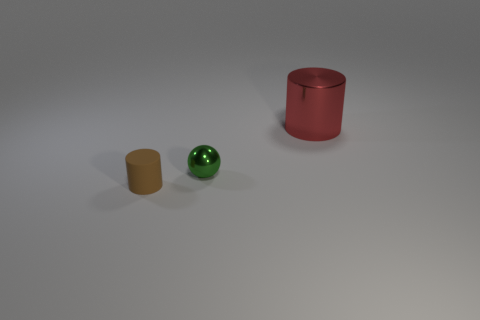There is a thing behind the green sphere; does it have the same color as the small metal ball?
Provide a short and direct response. No. How many green things are shiny spheres or metal cylinders?
Offer a very short reply. 1. What number of other objects are the same shape as the tiny matte thing?
Your answer should be very brief. 1. Does the tiny brown cylinder have the same material as the large object?
Offer a terse response. No. What material is the thing that is on the left side of the large red shiny thing and behind the brown cylinder?
Offer a very short reply. Metal. The metallic object in front of the big object is what color?
Offer a very short reply. Green. Is the number of small brown cylinders that are on the right side of the small green sphere greater than the number of cyan shiny things?
Ensure brevity in your answer.  No. What number of other objects are there of the same size as the red thing?
Offer a terse response. 0. There is a red metal cylinder; how many metallic objects are in front of it?
Ensure brevity in your answer.  1. Is the number of brown things behind the big metal object the same as the number of green balls in front of the brown object?
Keep it short and to the point. Yes. 